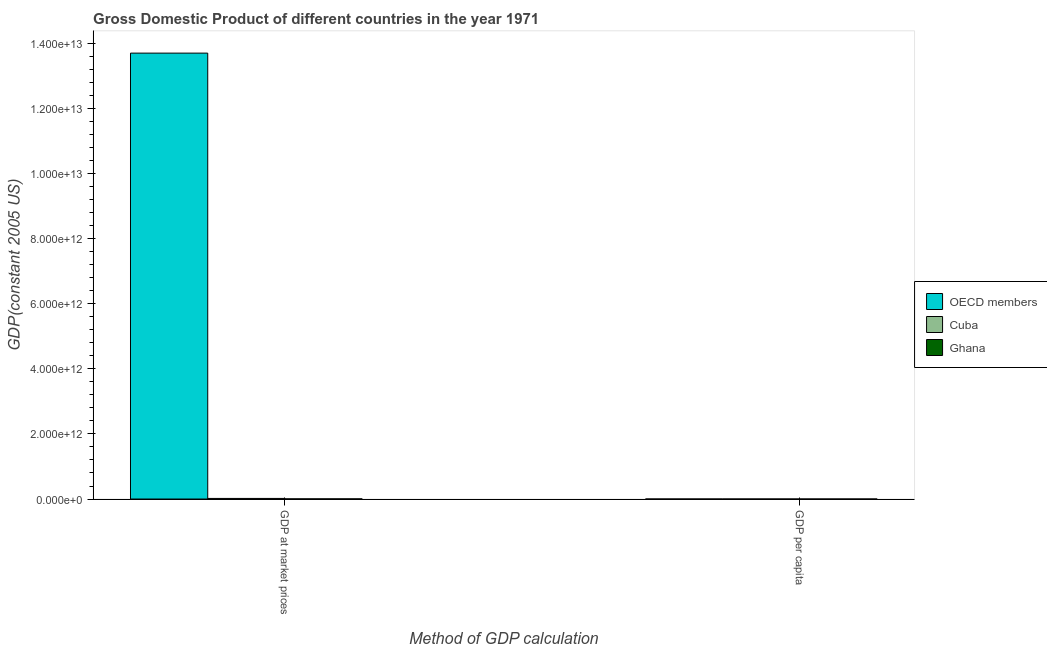How many bars are there on the 1st tick from the right?
Ensure brevity in your answer.  3. What is the label of the 2nd group of bars from the left?
Your response must be concise. GDP per capita. What is the gdp per capita in Cuba?
Give a very brief answer. 2067.92. Across all countries, what is the maximum gdp at market prices?
Give a very brief answer. 1.37e+13. Across all countries, what is the minimum gdp per capita?
Give a very brief answer. 512.47. In which country was the gdp at market prices maximum?
Ensure brevity in your answer.  OECD members. In which country was the gdp per capita minimum?
Provide a short and direct response. Ghana. What is the total gdp at market prices in the graph?
Provide a succinct answer. 1.37e+13. What is the difference between the gdp at market prices in Ghana and that in OECD members?
Offer a very short reply. -1.37e+13. What is the difference between the gdp per capita in OECD members and the gdp at market prices in Cuba?
Provide a short and direct response. -1.83e+1. What is the average gdp at market prices per country?
Provide a succinct answer. 4.57e+12. What is the difference between the gdp at market prices and gdp per capita in Ghana?
Provide a short and direct response. 4.52e+09. What is the ratio of the gdp per capita in Cuba to that in OECD members?
Give a very brief answer. 0.14. Is the gdp at market prices in Ghana less than that in Cuba?
Offer a very short reply. Yes. In how many countries, is the gdp at market prices greater than the average gdp at market prices taken over all countries?
Ensure brevity in your answer.  1. What does the 3rd bar from the left in GDP per capita represents?
Offer a terse response. Ghana. What does the 3rd bar from the right in GDP at market prices represents?
Make the answer very short. OECD members. What is the difference between two consecutive major ticks on the Y-axis?
Make the answer very short. 2.00e+12. Are the values on the major ticks of Y-axis written in scientific E-notation?
Your answer should be very brief. Yes. Does the graph contain any zero values?
Your response must be concise. No. Where does the legend appear in the graph?
Provide a succinct answer. Center right. How are the legend labels stacked?
Offer a terse response. Vertical. What is the title of the graph?
Make the answer very short. Gross Domestic Product of different countries in the year 1971. Does "Kuwait" appear as one of the legend labels in the graph?
Provide a short and direct response. No. What is the label or title of the X-axis?
Your answer should be very brief. Method of GDP calculation. What is the label or title of the Y-axis?
Give a very brief answer. GDP(constant 2005 US). What is the GDP(constant 2005 US) in OECD members in GDP at market prices?
Your answer should be very brief. 1.37e+13. What is the GDP(constant 2005 US) of Cuba in GDP at market prices?
Your answer should be very brief. 1.83e+1. What is the GDP(constant 2005 US) in Ghana in GDP at market prices?
Keep it short and to the point. 4.52e+09. What is the GDP(constant 2005 US) of OECD members in GDP per capita?
Give a very brief answer. 1.52e+04. What is the GDP(constant 2005 US) in Cuba in GDP per capita?
Provide a short and direct response. 2067.92. What is the GDP(constant 2005 US) in Ghana in GDP per capita?
Your answer should be compact. 512.47. Across all Method of GDP calculation, what is the maximum GDP(constant 2005 US) of OECD members?
Make the answer very short. 1.37e+13. Across all Method of GDP calculation, what is the maximum GDP(constant 2005 US) in Cuba?
Make the answer very short. 1.83e+1. Across all Method of GDP calculation, what is the maximum GDP(constant 2005 US) in Ghana?
Make the answer very short. 4.52e+09. Across all Method of GDP calculation, what is the minimum GDP(constant 2005 US) in OECD members?
Keep it short and to the point. 1.52e+04. Across all Method of GDP calculation, what is the minimum GDP(constant 2005 US) in Cuba?
Offer a terse response. 2067.92. Across all Method of GDP calculation, what is the minimum GDP(constant 2005 US) of Ghana?
Your answer should be compact. 512.47. What is the total GDP(constant 2005 US) of OECD members in the graph?
Your answer should be compact. 1.37e+13. What is the total GDP(constant 2005 US) in Cuba in the graph?
Your response must be concise. 1.83e+1. What is the total GDP(constant 2005 US) in Ghana in the graph?
Keep it short and to the point. 4.52e+09. What is the difference between the GDP(constant 2005 US) of OECD members in GDP at market prices and that in GDP per capita?
Give a very brief answer. 1.37e+13. What is the difference between the GDP(constant 2005 US) in Cuba in GDP at market prices and that in GDP per capita?
Keep it short and to the point. 1.83e+1. What is the difference between the GDP(constant 2005 US) of Ghana in GDP at market prices and that in GDP per capita?
Your answer should be very brief. 4.52e+09. What is the difference between the GDP(constant 2005 US) of OECD members in GDP at market prices and the GDP(constant 2005 US) of Cuba in GDP per capita?
Make the answer very short. 1.37e+13. What is the difference between the GDP(constant 2005 US) of OECD members in GDP at market prices and the GDP(constant 2005 US) of Ghana in GDP per capita?
Your response must be concise. 1.37e+13. What is the difference between the GDP(constant 2005 US) of Cuba in GDP at market prices and the GDP(constant 2005 US) of Ghana in GDP per capita?
Provide a succinct answer. 1.83e+1. What is the average GDP(constant 2005 US) of OECD members per Method of GDP calculation?
Keep it short and to the point. 6.85e+12. What is the average GDP(constant 2005 US) of Cuba per Method of GDP calculation?
Make the answer very short. 9.17e+09. What is the average GDP(constant 2005 US) in Ghana per Method of GDP calculation?
Make the answer very short. 2.26e+09. What is the difference between the GDP(constant 2005 US) of OECD members and GDP(constant 2005 US) of Cuba in GDP at market prices?
Your response must be concise. 1.37e+13. What is the difference between the GDP(constant 2005 US) of OECD members and GDP(constant 2005 US) of Ghana in GDP at market prices?
Make the answer very short. 1.37e+13. What is the difference between the GDP(constant 2005 US) in Cuba and GDP(constant 2005 US) in Ghana in GDP at market prices?
Provide a succinct answer. 1.38e+1. What is the difference between the GDP(constant 2005 US) in OECD members and GDP(constant 2005 US) in Cuba in GDP per capita?
Ensure brevity in your answer.  1.31e+04. What is the difference between the GDP(constant 2005 US) of OECD members and GDP(constant 2005 US) of Ghana in GDP per capita?
Offer a terse response. 1.47e+04. What is the difference between the GDP(constant 2005 US) in Cuba and GDP(constant 2005 US) in Ghana in GDP per capita?
Keep it short and to the point. 1555.44. What is the ratio of the GDP(constant 2005 US) of OECD members in GDP at market prices to that in GDP per capita?
Offer a terse response. 9.01e+08. What is the ratio of the GDP(constant 2005 US) of Cuba in GDP at market prices to that in GDP per capita?
Make the answer very short. 8.87e+06. What is the ratio of the GDP(constant 2005 US) of Ghana in GDP at market prices to that in GDP per capita?
Make the answer very short. 8.83e+06. What is the difference between the highest and the second highest GDP(constant 2005 US) in OECD members?
Your answer should be compact. 1.37e+13. What is the difference between the highest and the second highest GDP(constant 2005 US) of Cuba?
Your answer should be very brief. 1.83e+1. What is the difference between the highest and the second highest GDP(constant 2005 US) of Ghana?
Offer a very short reply. 4.52e+09. What is the difference between the highest and the lowest GDP(constant 2005 US) of OECD members?
Ensure brevity in your answer.  1.37e+13. What is the difference between the highest and the lowest GDP(constant 2005 US) in Cuba?
Offer a very short reply. 1.83e+1. What is the difference between the highest and the lowest GDP(constant 2005 US) of Ghana?
Provide a short and direct response. 4.52e+09. 